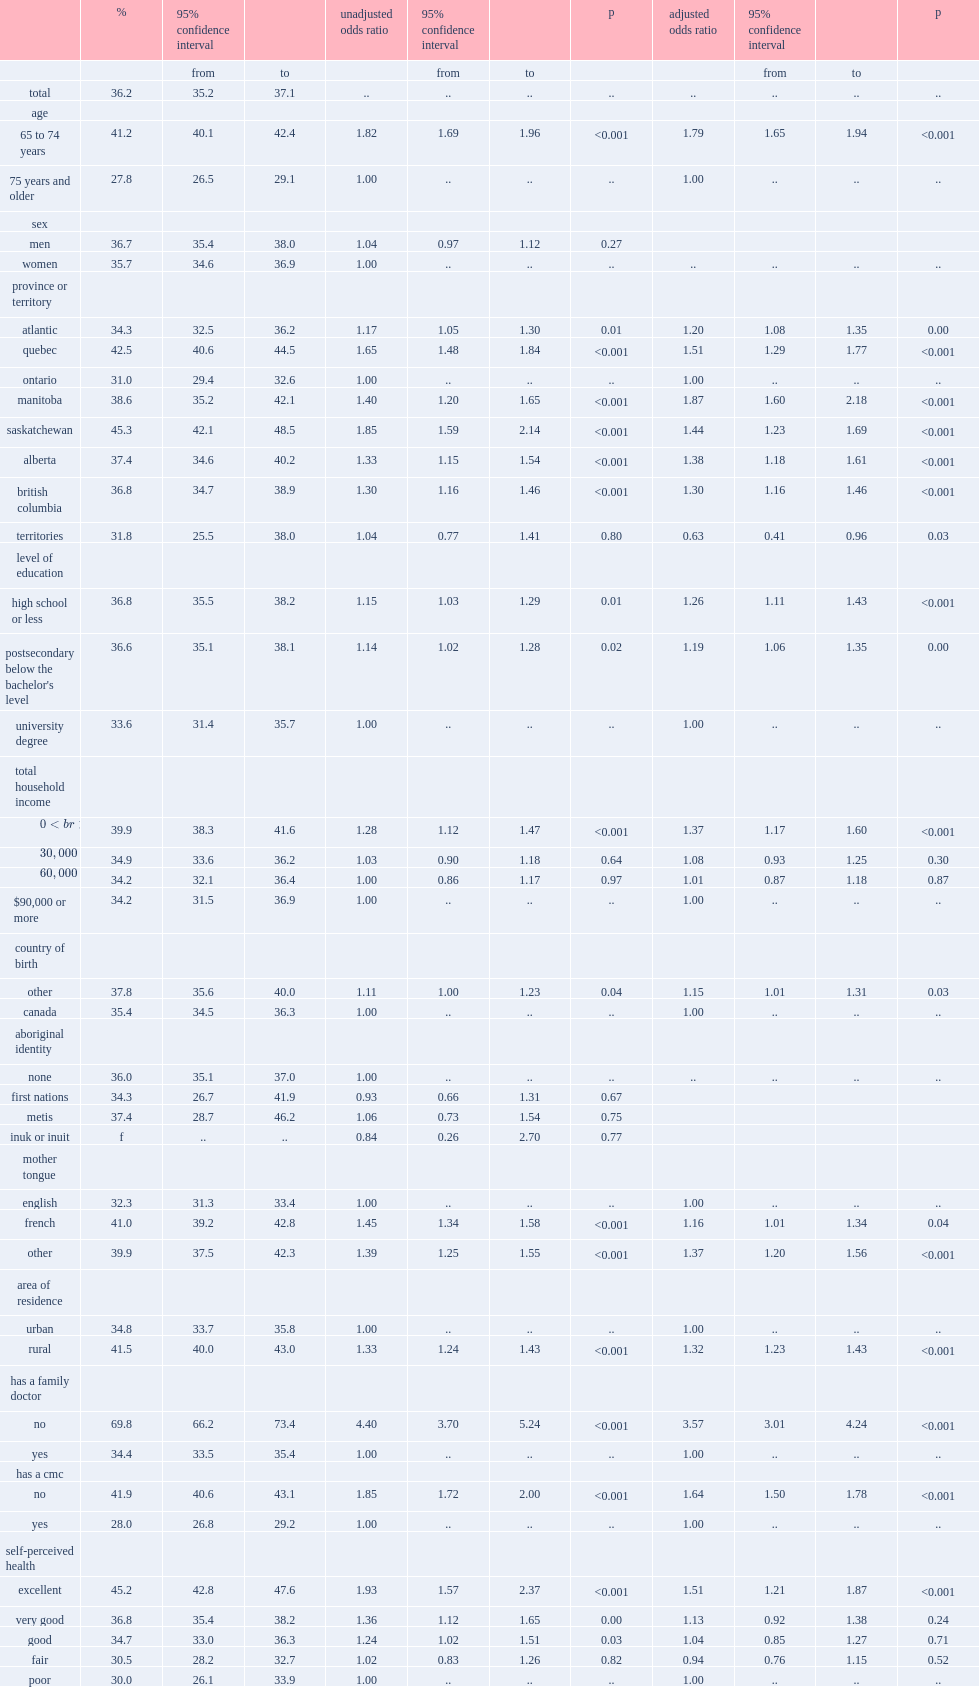Which kind of adults aged 65 years and older has the lowest proportion? Has a cmc yes. What is the lowest proportion observed among adults aged 65 years and older? 28.0. Which factor is most strongly associated with non-vaccination in this group? No has a family doctor. 